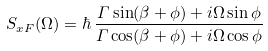Convert formula to latex. <formula><loc_0><loc_0><loc_500><loc_500>S _ { x F } ( \Omega ) = \hbar { \, } \frac { \varGamma \sin ( \beta + \phi ) + i \Omega \sin \phi } { \varGamma \cos ( \beta + \phi ) + i \Omega \cos \phi }</formula> 